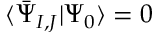Convert formula to latex. <formula><loc_0><loc_0><loc_500><loc_500>{ \langle \bar { \Psi } _ { I , J } | \Psi _ { 0 } \rangle } = 0</formula> 